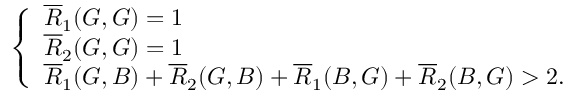<formula> <loc_0><loc_0><loc_500><loc_500>\left \{ \begin{array} { l l } { \overline { R } _ { 1 } ( G , G ) = 1 } \\ { \overline { R } _ { 2 } ( G , G ) = 1 } \\ { \overline { R } _ { 1 } ( G , B ) + \overline { R } _ { 2 } ( G , B ) + \overline { R } _ { 1 } ( B , G ) + \overline { R } _ { 2 } ( B , G ) > 2 . } \end{array}</formula> 